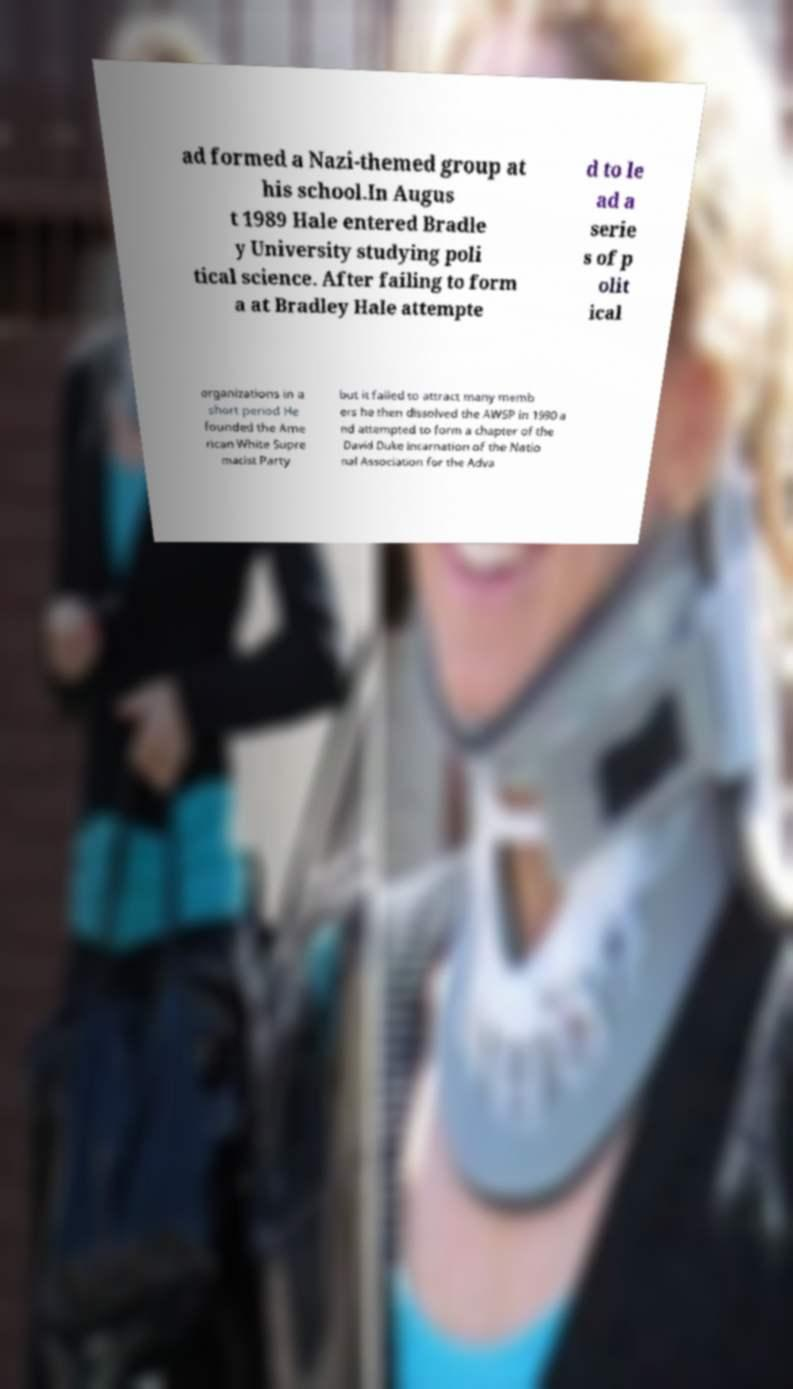I need the written content from this picture converted into text. Can you do that? ad formed a Nazi-themed group at his school.In Augus t 1989 Hale entered Bradle y University studying poli tical science. After failing to form a at Bradley Hale attempte d to le ad a serie s of p olit ical organizations in a short period He founded the Ame rican White Supre macist Party but it failed to attract many memb ers he then dissolved the AWSP in 1990 a nd attempted to form a chapter of the David Duke incarnation of the Natio nal Association for the Adva 